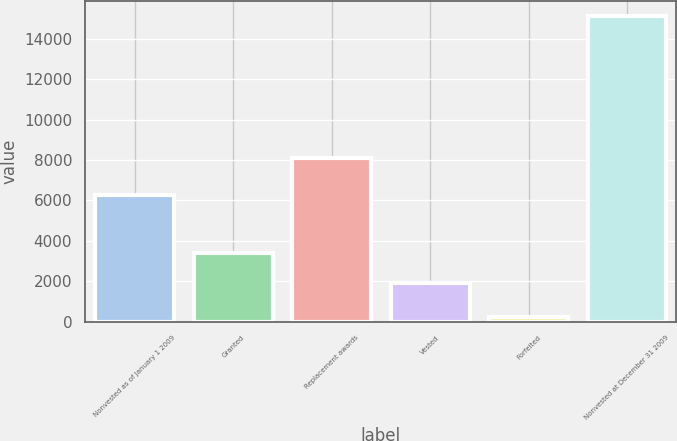<chart> <loc_0><loc_0><loc_500><loc_500><bar_chart><fcel>Nonvested as of January 1 2009<fcel>Granted<fcel>Replacement awards<fcel>Vested<fcel>Forfeited<fcel>Nonvested at December 31 2009<nl><fcel>6292.2<fcel>3388.37<fcel>8105.6<fcel>1896.6<fcel>201<fcel>15118.7<nl></chart> 